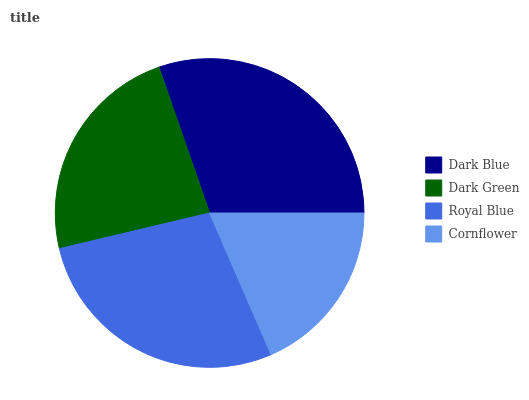Is Cornflower the minimum?
Answer yes or no. Yes. Is Dark Blue the maximum?
Answer yes or no. Yes. Is Dark Green the minimum?
Answer yes or no. No. Is Dark Green the maximum?
Answer yes or no. No. Is Dark Blue greater than Dark Green?
Answer yes or no. Yes. Is Dark Green less than Dark Blue?
Answer yes or no. Yes. Is Dark Green greater than Dark Blue?
Answer yes or no. No. Is Dark Blue less than Dark Green?
Answer yes or no. No. Is Royal Blue the high median?
Answer yes or no. Yes. Is Dark Green the low median?
Answer yes or no. Yes. Is Dark Green the high median?
Answer yes or no. No. Is Royal Blue the low median?
Answer yes or no. No. 